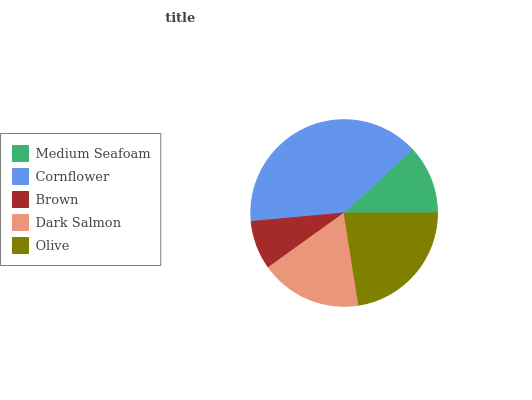Is Brown the minimum?
Answer yes or no. Yes. Is Cornflower the maximum?
Answer yes or no. Yes. Is Cornflower the minimum?
Answer yes or no. No. Is Brown the maximum?
Answer yes or no. No. Is Cornflower greater than Brown?
Answer yes or no. Yes. Is Brown less than Cornflower?
Answer yes or no. Yes. Is Brown greater than Cornflower?
Answer yes or no. No. Is Cornflower less than Brown?
Answer yes or no. No. Is Dark Salmon the high median?
Answer yes or no. Yes. Is Dark Salmon the low median?
Answer yes or no. Yes. Is Olive the high median?
Answer yes or no. No. Is Medium Seafoam the low median?
Answer yes or no. No. 